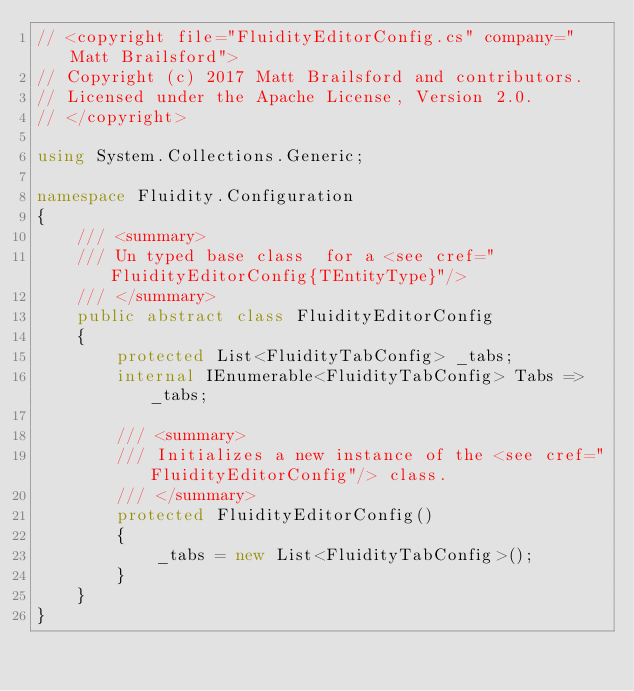Convert code to text. <code><loc_0><loc_0><loc_500><loc_500><_C#_>// <copyright file="FluidityEditorConfig.cs" company="Matt Brailsford">
// Copyright (c) 2017 Matt Brailsford and contributors.
// Licensed under the Apache License, Version 2.0.
// </copyright>

using System.Collections.Generic;

namespace Fluidity.Configuration
{
    /// <summary>
    /// Un typed base class  for a <see cref="FluidityEditorConfig{TEntityType}"/>
    /// </summary>
    public abstract class FluidityEditorConfig
    {
        protected List<FluidityTabConfig> _tabs;
        internal IEnumerable<FluidityTabConfig> Tabs => _tabs;

        /// <summary>
        /// Initializes a new instance of the <see cref="FluidityEditorConfig"/> class.
        /// </summary>
        protected FluidityEditorConfig()
        {
            _tabs = new List<FluidityTabConfig>();
        }
    }
}</code> 